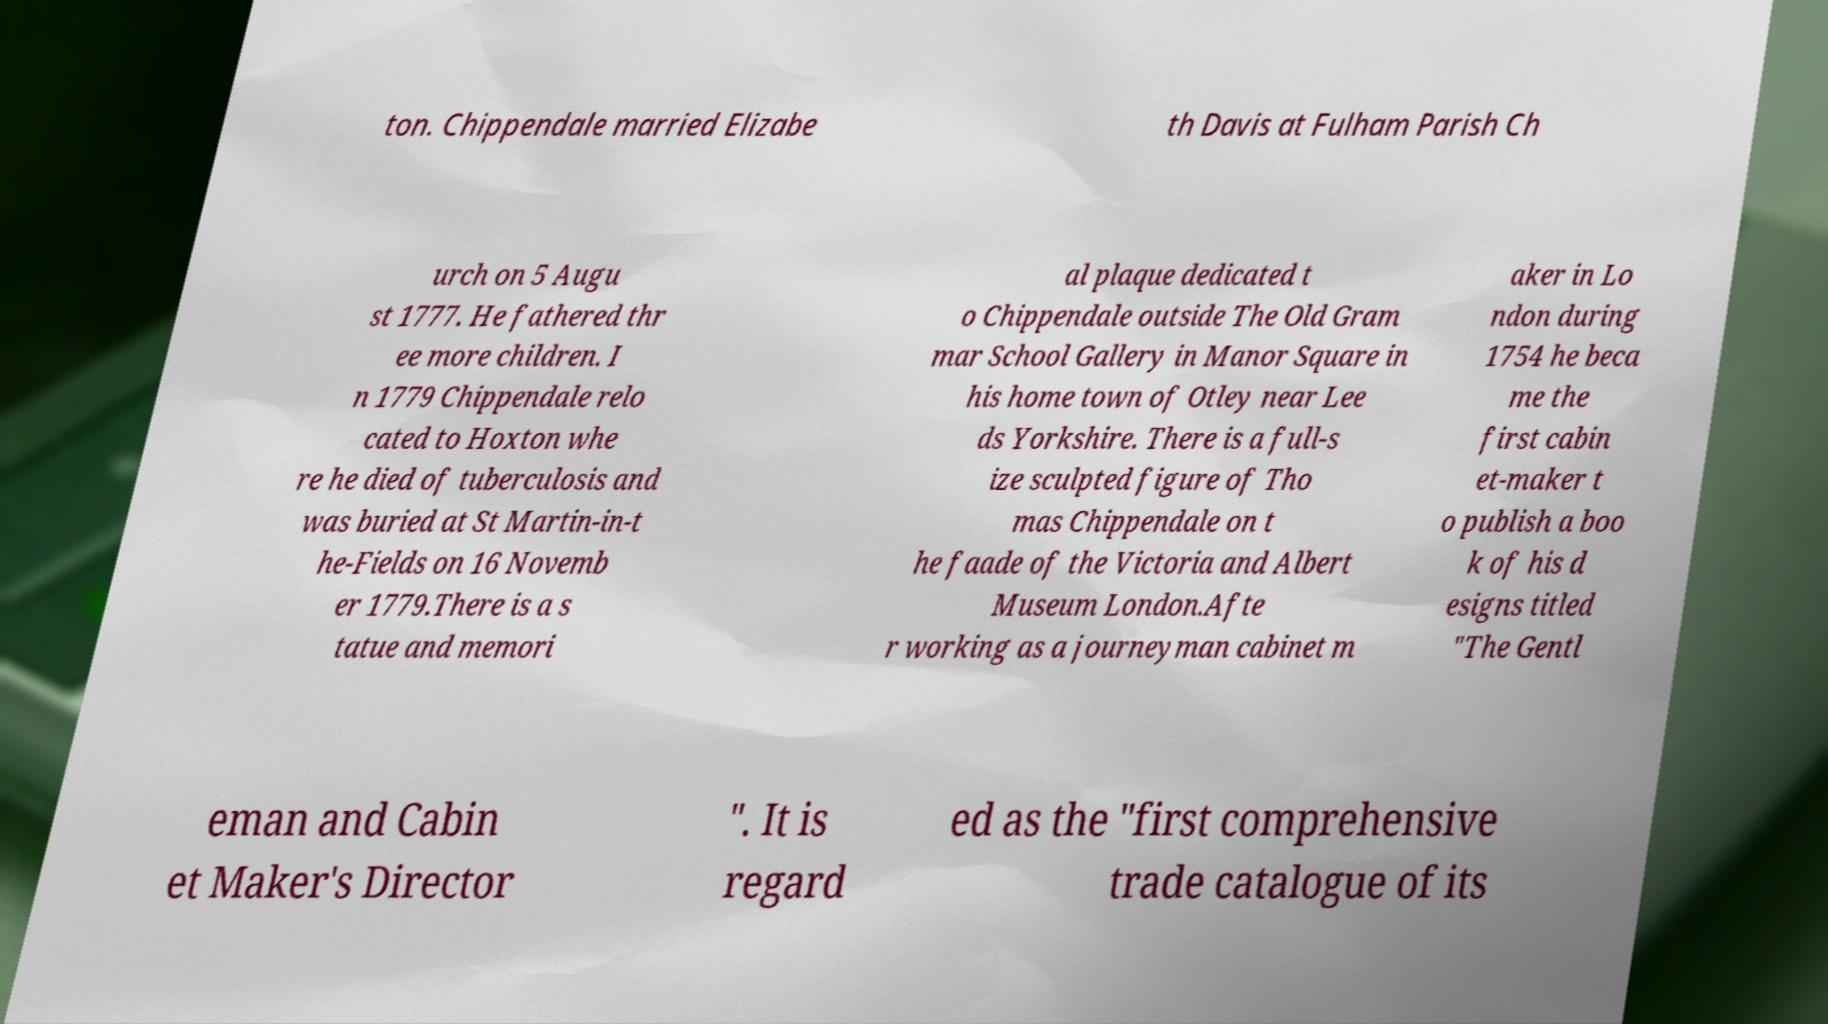For documentation purposes, I need the text within this image transcribed. Could you provide that? ton. Chippendale married Elizabe th Davis at Fulham Parish Ch urch on 5 Augu st 1777. He fathered thr ee more children. I n 1779 Chippendale relo cated to Hoxton whe re he died of tuberculosis and was buried at St Martin-in-t he-Fields on 16 Novemb er 1779.There is a s tatue and memori al plaque dedicated t o Chippendale outside The Old Gram mar School Gallery in Manor Square in his home town of Otley near Lee ds Yorkshire. There is a full-s ize sculpted figure of Tho mas Chippendale on t he faade of the Victoria and Albert Museum London.Afte r working as a journeyman cabinet m aker in Lo ndon during 1754 he beca me the first cabin et-maker t o publish a boo k of his d esigns titled "The Gentl eman and Cabin et Maker's Director ". It is regard ed as the "first comprehensive trade catalogue of its 